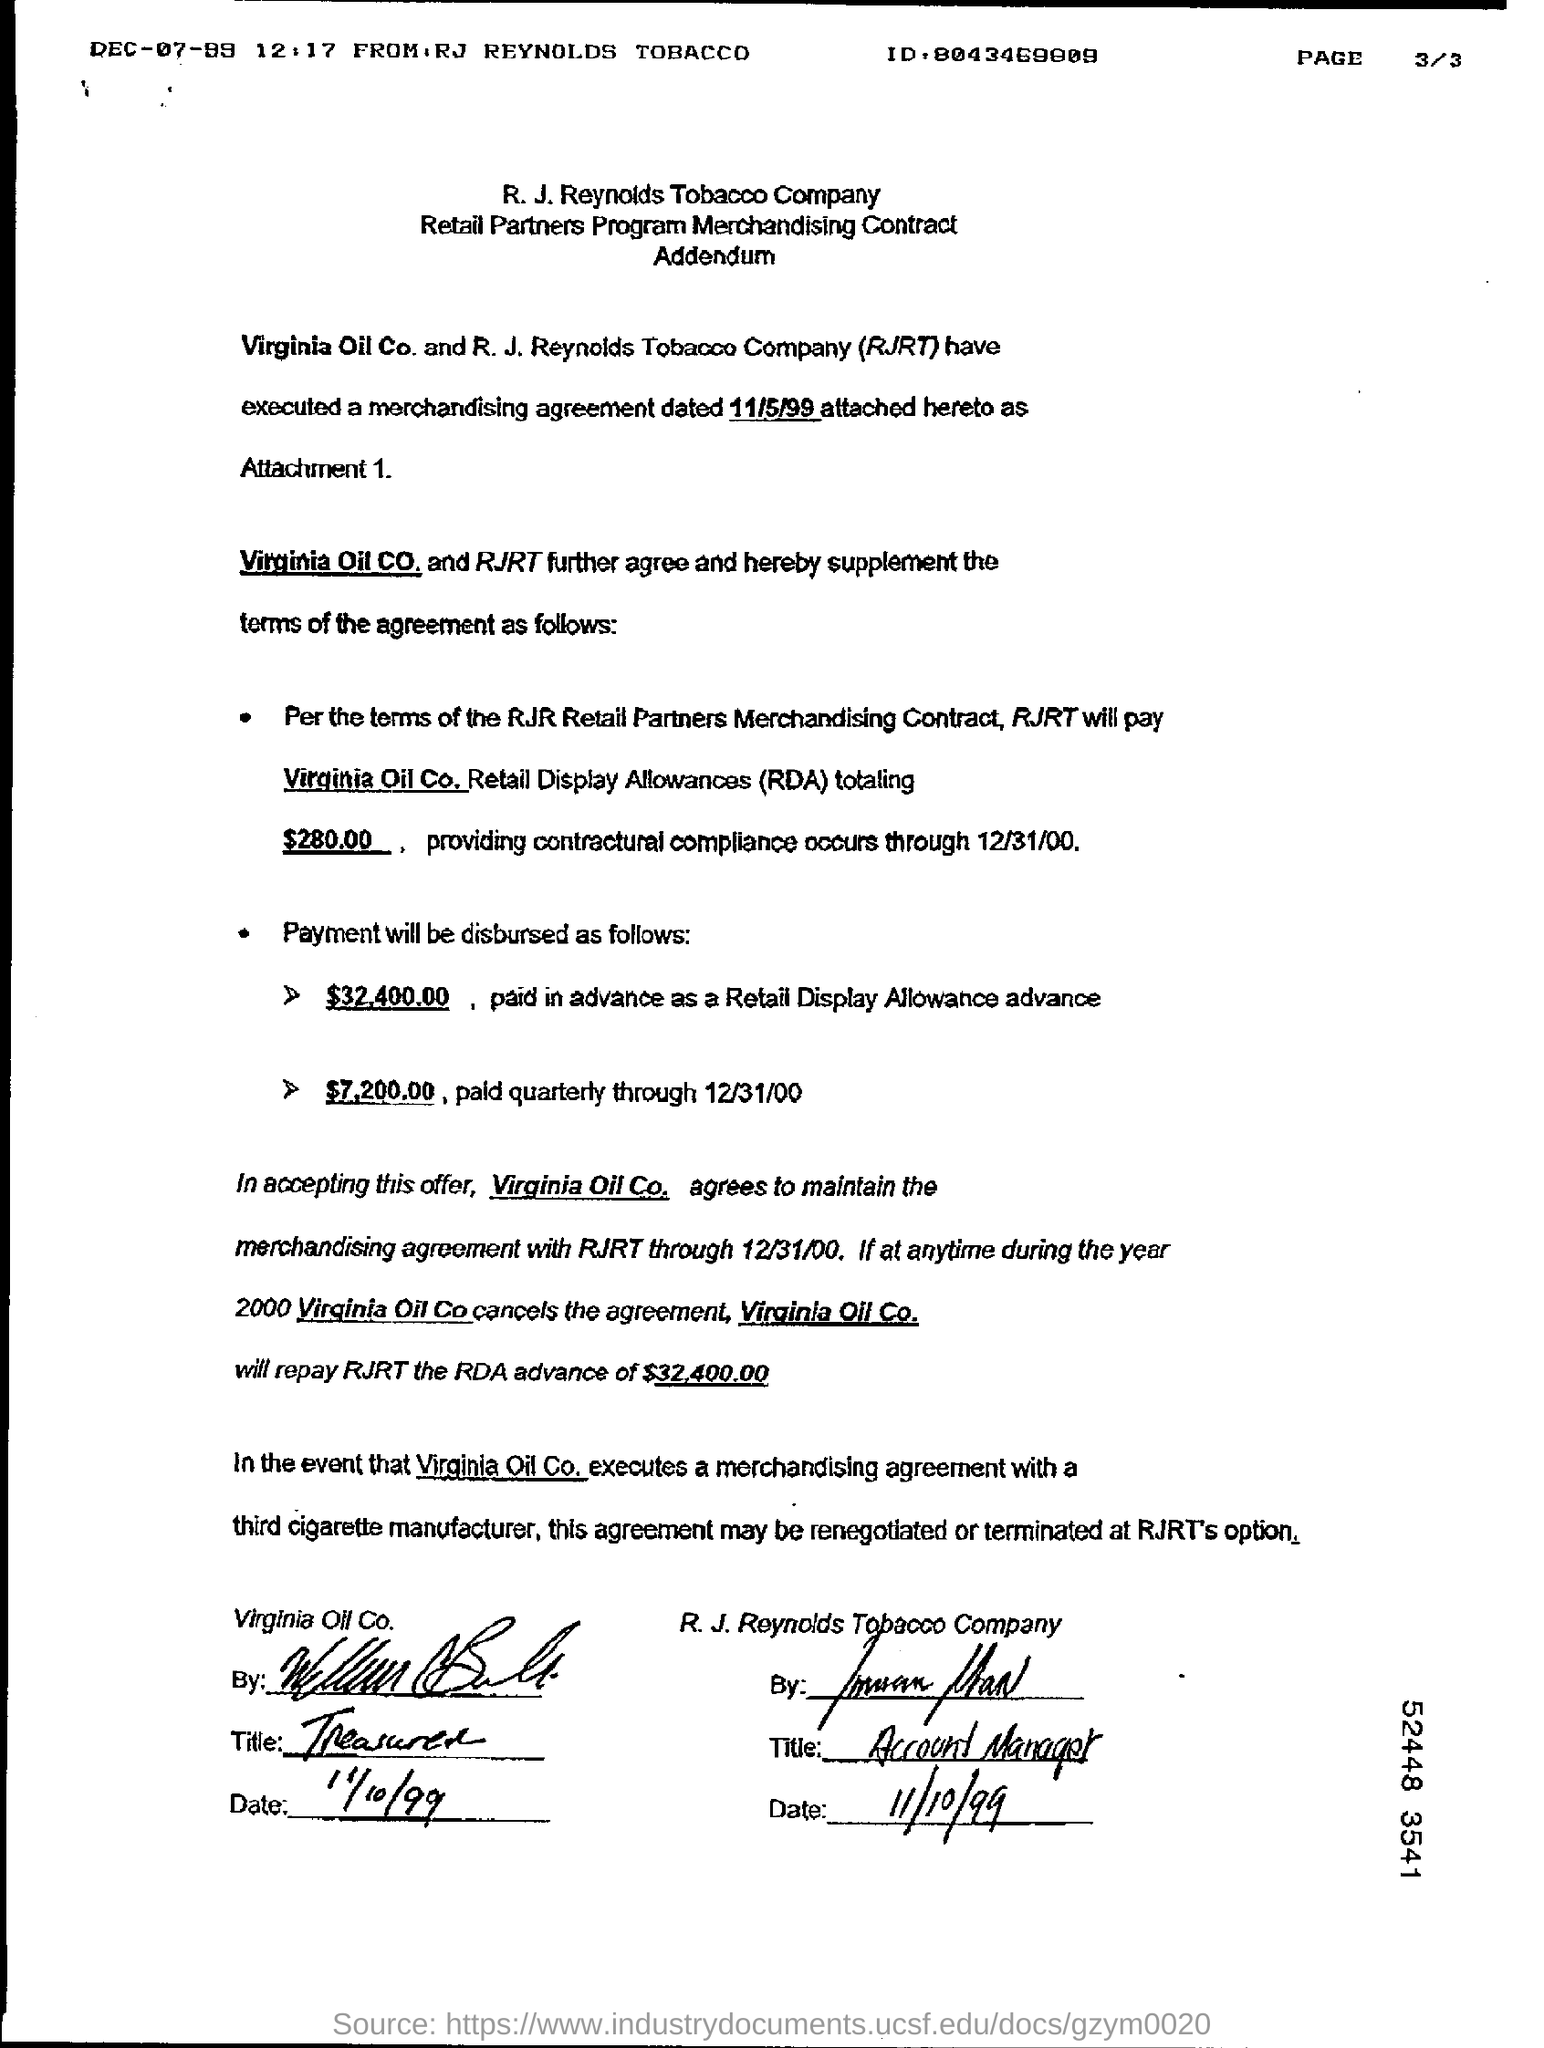Mention a couple of crucial points in this snapshot. The agreement is dated November 5, 1999. 